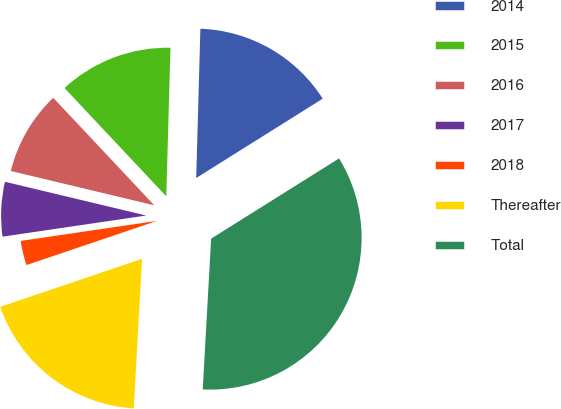Convert chart. <chart><loc_0><loc_0><loc_500><loc_500><pie_chart><fcel>2014<fcel>2015<fcel>2016<fcel>2017<fcel>2018<fcel>Thereafter<fcel>Total<nl><fcel>15.64%<fcel>12.45%<fcel>9.26%<fcel>6.06%<fcel>2.87%<fcel>18.92%<fcel>34.8%<nl></chart> 